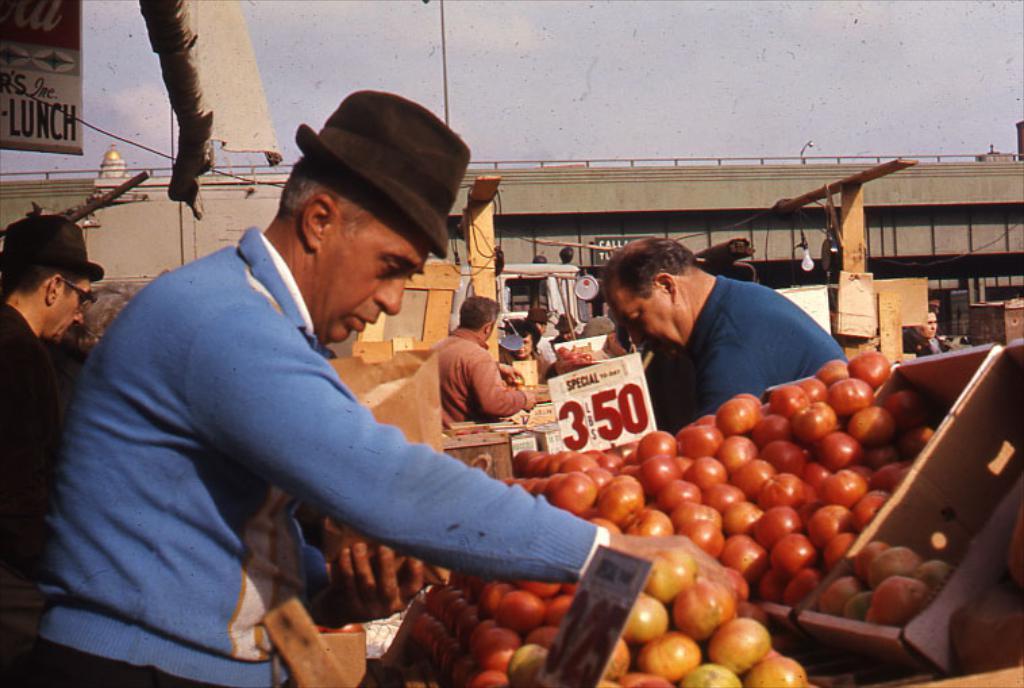In one or two sentences, can you explain what this image depicts? This image consists of some persons. There are fruits in this image. There is bridge in the middle. There is sky at the top. 